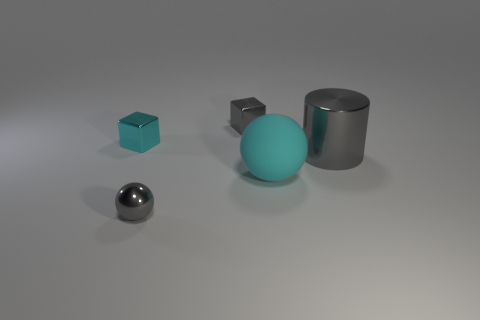Subtract 1 cyan spheres. How many objects are left? 4 Subtract all blocks. How many objects are left? 3 Subtract 1 cubes. How many cubes are left? 1 Subtract all red cylinders. Subtract all green blocks. How many cylinders are left? 1 Subtract all green cylinders. How many blue spheres are left? 0 Subtract all gray metallic balls. Subtract all tiny cyan things. How many objects are left? 3 Add 5 tiny gray shiny balls. How many tiny gray shiny balls are left? 6 Add 1 big gray matte cylinders. How many big gray matte cylinders exist? 1 Add 3 large gray cylinders. How many objects exist? 8 Subtract all cyan cubes. How many cubes are left? 1 